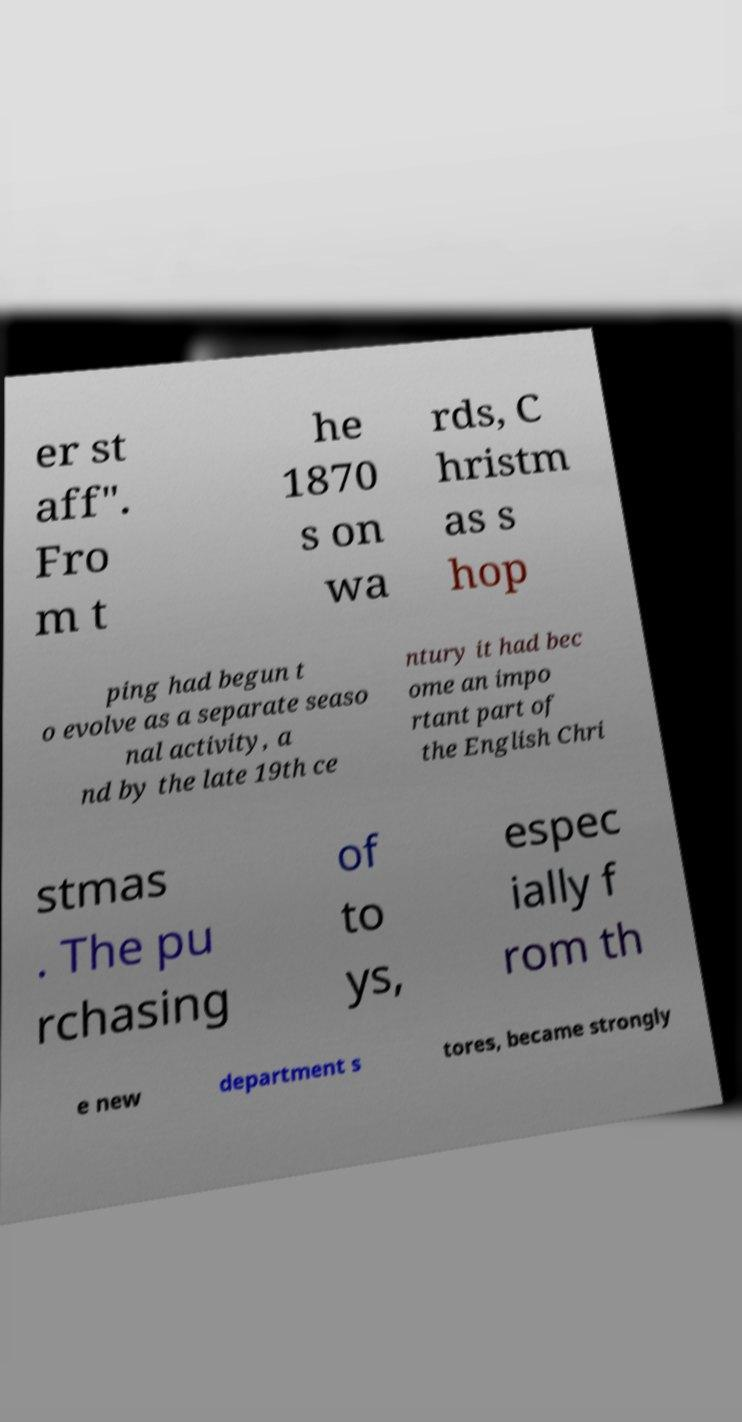There's text embedded in this image that I need extracted. Can you transcribe it verbatim? er st aff". Fro m t he 1870 s on wa rds, C hristm as s hop ping had begun t o evolve as a separate seaso nal activity, a nd by the late 19th ce ntury it had bec ome an impo rtant part of the English Chri stmas . The pu rchasing of to ys, espec ially f rom th e new department s tores, became strongly 